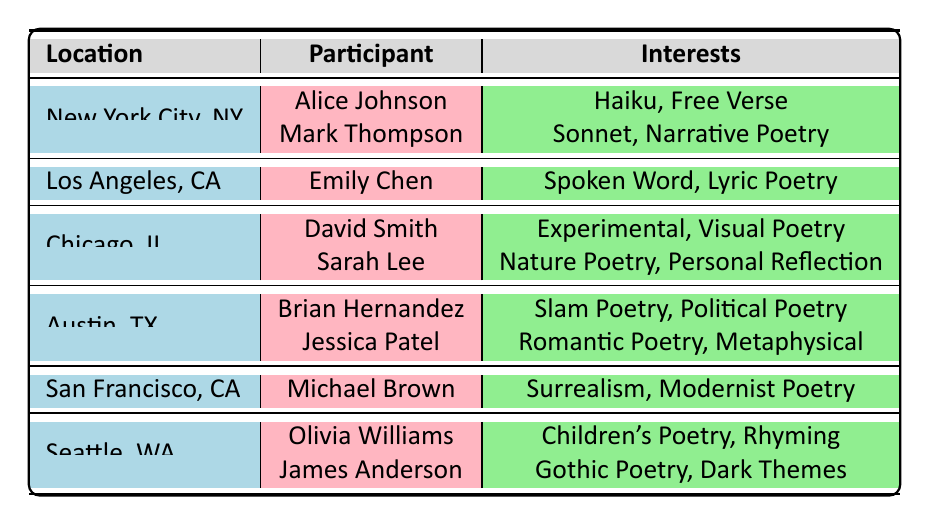What are the interests of participants from New York City? The table shows that Alice Johnson has interests in "Haiku" and "Free Verse," while Mark Thompson is interested in "Sonnet" and "Narrative Poetry."
Answer: Haiku, Free Verse; Sonnet, Narrative Poetry Which location has the participant with the highest age? The oldest participant listed is David Smith from Chicago, who is 42 years old, which is higher than all other participants.
Answer: Chicago, IL Are there any participants from Los Angeles? Yes, the table lists Emily Chen as a participant from Los Angeles, CA, with interests in "Spoken Word" and "Lyric Poetry."
Answer: Yes How many participants in total are listed in the table? Counting all participants from each location: 2 from New York City, 1 from Los Angeles, 2 from Chicago, 2 from Austin, 1 from San Francisco, and 2 from Seattle yields a total of 10 participants.
Answer: 10 What is the most common interest among all participants? The interests listed are varied; some participants share interests (e.g., poetry styles), but no single interest is repeated among all participants. Therefore, it's difficult to pinpoint a "most common" interest.
Answer: N/A (no common interest) Which location has the fewest participants? San Francisco, CA has only one participant, Michael Brown, whereas other locations have two or more participants.
Answer: San Francisco, CA What is the age difference between the youngest and oldest participants? The youngest participant is Brian Hernandez from Austin, who is 22 years old, and the oldest is David Smith from Chicago, who is 42. The age difference is calculated as 42 - 22 = 20 years.
Answer: 20 years Do any participants share the same interests? No pairs of participants have exactly the same interests listed; each participant has unique combinations of interests.
Answer: No How many participants are interested in poetry styles that involve personal expression, like "Personal Reflection" or "Lyric Poetry"? Sarah Lee's interest in "Personal Reflection" adds one, while Emily Chen’s interest in "Lyric Poetry" adds another, giving us a total of 2 participants with such interests.
Answer: 2 Which background is most common among participants? The backgrounds indicated include Creative Writing, Literature, Performing Arts, Fine Arts, Environmental Studies, Social Sciences, Philosophy, and Education, but there is no repeating background among participants.
Answer: N/A (no common background) 